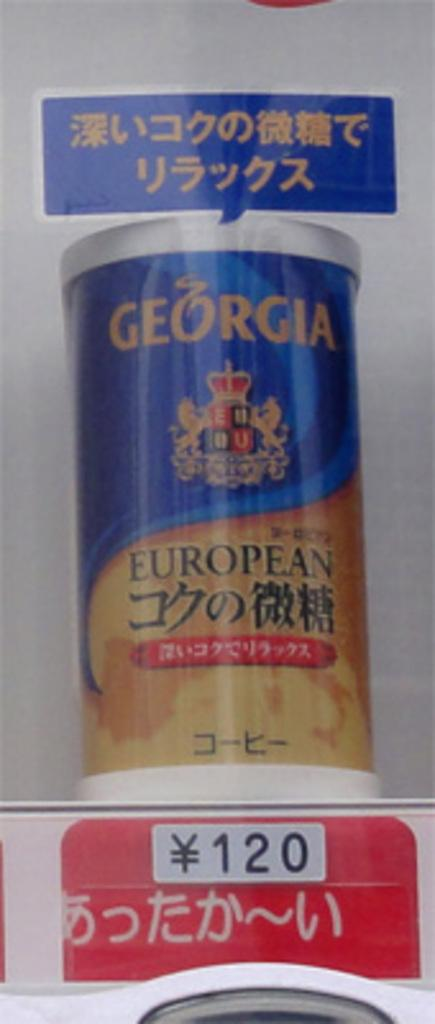<image>
Create a compact narrative representing the image presented. A can of Georgia European is for sale in an Asian store. 